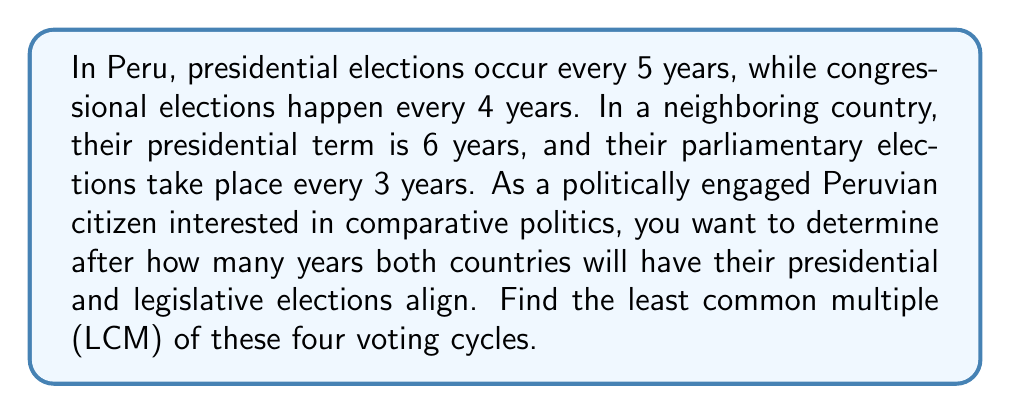Provide a solution to this math problem. To solve this problem, we need to find the LCM of 5, 4, 6, and 3 years. Let's approach this step-by-step:

1. First, let's find the prime factorization of each number:
   $5 = 5$
   $4 = 2^2$
   $6 = 2 \times 3$
   $3 = 3$

2. To find the LCM, we need to take each prime factor to the highest power in which it occurs in any of the numbers:
   
   $2$ appears with a maximum power of 2 (in 4)
   $3$ appears with a maximum power of 1 (in 3 and 6)
   $5$ appears with a maximum power of 1 (in 5)

3. The LCM will be the product of these highest powers:

   $LCM = 2^2 \times 3^1 \times 5^1$

4. Calculate the result:
   $LCM = 4 \times 3 \times 5 = 60$

Therefore, the voting cycles of both countries will align every 60 years.

This result has an interesting interpretation in the context of Peruvian and regional politics. It shows how infrequently the political cycles of different systems align, which could have implications for regional cooperation and comparative political analysis.
Answer: $60$ years 